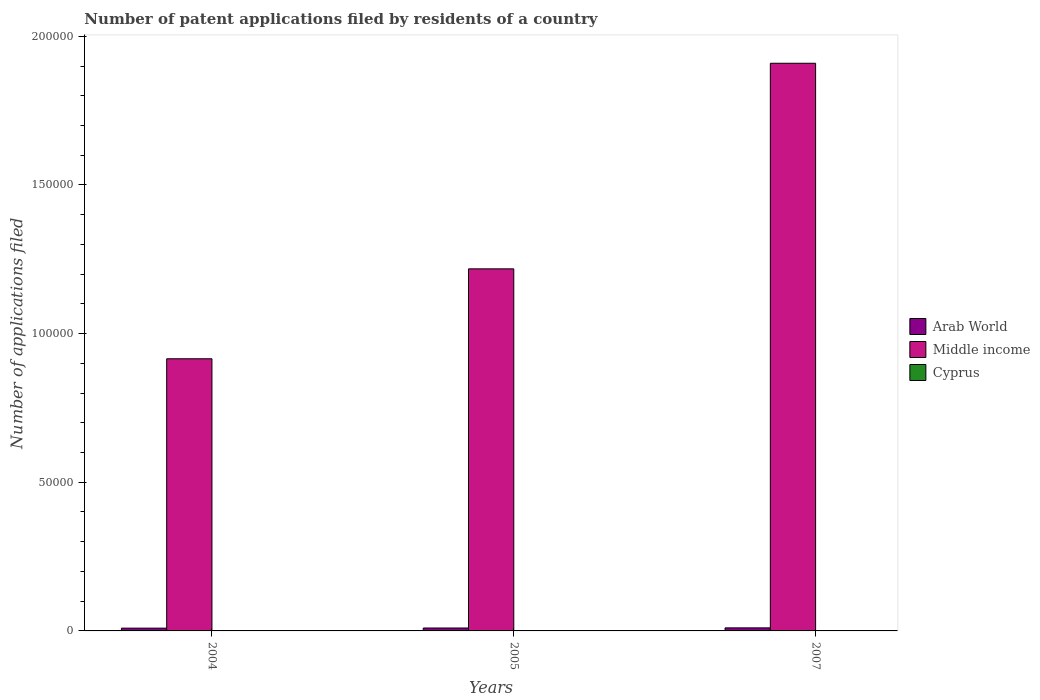How many different coloured bars are there?
Provide a succinct answer. 3. How many groups of bars are there?
Offer a very short reply. 3. How many bars are there on the 2nd tick from the left?
Make the answer very short. 3. What is the number of applications filed in Cyprus in 2004?
Ensure brevity in your answer.  9. Across all years, what is the maximum number of applications filed in Middle income?
Your response must be concise. 1.91e+05. Across all years, what is the minimum number of applications filed in Middle income?
Offer a terse response. 9.15e+04. In which year was the number of applications filed in Cyprus maximum?
Your response must be concise. 2005. In which year was the number of applications filed in Middle income minimum?
Make the answer very short. 2004. What is the difference between the number of applications filed in Arab World in 2004 and that in 2005?
Keep it short and to the point. -50. What is the difference between the number of applications filed in Cyprus in 2007 and the number of applications filed in Arab World in 2005?
Provide a succinct answer. -979. What is the average number of applications filed in Arab World per year?
Provide a short and direct response. 980.33. In the year 2005, what is the difference between the number of applications filed in Cyprus and number of applications filed in Middle income?
Make the answer very short. -1.22e+05. Is the number of applications filed in Cyprus in 2005 less than that in 2007?
Ensure brevity in your answer.  No. What is the difference between the highest and the second highest number of applications filed in Middle income?
Keep it short and to the point. 6.91e+04. What is the difference between the highest and the lowest number of applications filed in Arab World?
Offer a terse response. 95. Is the sum of the number of applications filed in Middle income in 2004 and 2005 greater than the maximum number of applications filed in Arab World across all years?
Keep it short and to the point. Yes. What does the 1st bar from the left in 2007 represents?
Keep it short and to the point. Arab World. What does the 3rd bar from the right in 2005 represents?
Provide a succinct answer. Arab World. How many bars are there?
Your answer should be compact. 9. How many years are there in the graph?
Offer a terse response. 3. What is the difference between two consecutive major ticks on the Y-axis?
Give a very brief answer. 5.00e+04. Does the graph contain any zero values?
Keep it short and to the point. No. Does the graph contain grids?
Provide a short and direct response. No. Where does the legend appear in the graph?
Offer a very short reply. Center right. How many legend labels are there?
Make the answer very short. 3. How are the legend labels stacked?
Keep it short and to the point. Vertical. What is the title of the graph?
Your answer should be compact. Number of patent applications filed by residents of a country. What is the label or title of the X-axis?
Your answer should be very brief. Years. What is the label or title of the Y-axis?
Offer a terse response. Number of applications filed. What is the Number of applications filed in Arab World in 2004?
Your response must be concise. 932. What is the Number of applications filed of Middle income in 2004?
Your answer should be compact. 9.15e+04. What is the Number of applications filed in Arab World in 2005?
Provide a short and direct response. 982. What is the Number of applications filed in Middle income in 2005?
Ensure brevity in your answer.  1.22e+05. What is the Number of applications filed of Arab World in 2007?
Offer a very short reply. 1027. What is the Number of applications filed in Middle income in 2007?
Keep it short and to the point. 1.91e+05. Across all years, what is the maximum Number of applications filed of Arab World?
Give a very brief answer. 1027. Across all years, what is the maximum Number of applications filed in Middle income?
Keep it short and to the point. 1.91e+05. Across all years, what is the minimum Number of applications filed of Arab World?
Your answer should be compact. 932. Across all years, what is the minimum Number of applications filed of Middle income?
Provide a short and direct response. 9.15e+04. Across all years, what is the minimum Number of applications filed in Cyprus?
Ensure brevity in your answer.  3. What is the total Number of applications filed in Arab World in the graph?
Your response must be concise. 2941. What is the total Number of applications filed in Middle income in the graph?
Offer a very short reply. 4.04e+05. What is the total Number of applications filed in Cyprus in the graph?
Provide a succinct answer. 32. What is the difference between the Number of applications filed in Arab World in 2004 and that in 2005?
Your response must be concise. -50. What is the difference between the Number of applications filed of Middle income in 2004 and that in 2005?
Make the answer very short. -3.02e+04. What is the difference between the Number of applications filed in Cyprus in 2004 and that in 2005?
Provide a short and direct response. -11. What is the difference between the Number of applications filed of Arab World in 2004 and that in 2007?
Keep it short and to the point. -95. What is the difference between the Number of applications filed in Middle income in 2004 and that in 2007?
Ensure brevity in your answer.  -9.94e+04. What is the difference between the Number of applications filed of Cyprus in 2004 and that in 2007?
Keep it short and to the point. 6. What is the difference between the Number of applications filed in Arab World in 2005 and that in 2007?
Provide a succinct answer. -45. What is the difference between the Number of applications filed of Middle income in 2005 and that in 2007?
Ensure brevity in your answer.  -6.91e+04. What is the difference between the Number of applications filed of Arab World in 2004 and the Number of applications filed of Middle income in 2005?
Provide a succinct answer. -1.21e+05. What is the difference between the Number of applications filed in Arab World in 2004 and the Number of applications filed in Cyprus in 2005?
Make the answer very short. 912. What is the difference between the Number of applications filed of Middle income in 2004 and the Number of applications filed of Cyprus in 2005?
Keep it short and to the point. 9.15e+04. What is the difference between the Number of applications filed in Arab World in 2004 and the Number of applications filed in Middle income in 2007?
Your answer should be very brief. -1.90e+05. What is the difference between the Number of applications filed in Arab World in 2004 and the Number of applications filed in Cyprus in 2007?
Your answer should be compact. 929. What is the difference between the Number of applications filed in Middle income in 2004 and the Number of applications filed in Cyprus in 2007?
Ensure brevity in your answer.  9.15e+04. What is the difference between the Number of applications filed in Arab World in 2005 and the Number of applications filed in Middle income in 2007?
Give a very brief answer. -1.90e+05. What is the difference between the Number of applications filed of Arab World in 2005 and the Number of applications filed of Cyprus in 2007?
Provide a succinct answer. 979. What is the difference between the Number of applications filed of Middle income in 2005 and the Number of applications filed of Cyprus in 2007?
Provide a succinct answer. 1.22e+05. What is the average Number of applications filed in Arab World per year?
Give a very brief answer. 980.33. What is the average Number of applications filed of Middle income per year?
Your answer should be very brief. 1.35e+05. What is the average Number of applications filed of Cyprus per year?
Your answer should be very brief. 10.67. In the year 2004, what is the difference between the Number of applications filed of Arab World and Number of applications filed of Middle income?
Ensure brevity in your answer.  -9.06e+04. In the year 2004, what is the difference between the Number of applications filed in Arab World and Number of applications filed in Cyprus?
Provide a succinct answer. 923. In the year 2004, what is the difference between the Number of applications filed in Middle income and Number of applications filed in Cyprus?
Keep it short and to the point. 9.15e+04. In the year 2005, what is the difference between the Number of applications filed of Arab World and Number of applications filed of Middle income?
Provide a short and direct response. -1.21e+05. In the year 2005, what is the difference between the Number of applications filed in Arab World and Number of applications filed in Cyprus?
Provide a short and direct response. 962. In the year 2005, what is the difference between the Number of applications filed of Middle income and Number of applications filed of Cyprus?
Make the answer very short. 1.22e+05. In the year 2007, what is the difference between the Number of applications filed in Arab World and Number of applications filed in Middle income?
Offer a terse response. -1.90e+05. In the year 2007, what is the difference between the Number of applications filed of Arab World and Number of applications filed of Cyprus?
Your answer should be very brief. 1024. In the year 2007, what is the difference between the Number of applications filed of Middle income and Number of applications filed of Cyprus?
Offer a terse response. 1.91e+05. What is the ratio of the Number of applications filed in Arab World in 2004 to that in 2005?
Your answer should be very brief. 0.95. What is the ratio of the Number of applications filed of Middle income in 2004 to that in 2005?
Keep it short and to the point. 0.75. What is the ratio of the Number of applications filed of Cyprus in 2004 to that in 2005?
Provide a short and direct response. 0.45. What is the ratio of the Number of applications filed of Arab World in 2004 to that in 2007?
Make the answer very short. 0.91. What is the ratio of the Number of applications filed in Middle income in 2004 to that in 2007?
Your answer should be very brief. 0.48. What is the ratio of the Number of applications filed of Cyprus in 2004 to that in 2007?
Give a very brief answer. 3. What is the ratio of the Number of applications filed in Arab World in 2005 to that in 2007?
Provide a succinct answer. 0.96. What is the ratio of the Number of applications filed of Middle income in 2005 to that in 2007?
Provide a succinct answer. 0.64. What is the ratio of the Number of applications filed of Cyprus in 2005 to that in 2007?
Your response must be concise. 6.67. What is the difference between the highest and the second highest Number of applications filed in Middle income?
Your answer should be very brief. 6.91e+04. What is the difference between the highest and the second highest Number of applications filed in Cyprus?
Your answer should be very brief. 11. What is the difference between the highest and the lowest Number of applications filed in Middle income?
Give a very brief answer. 9.94e+04. 